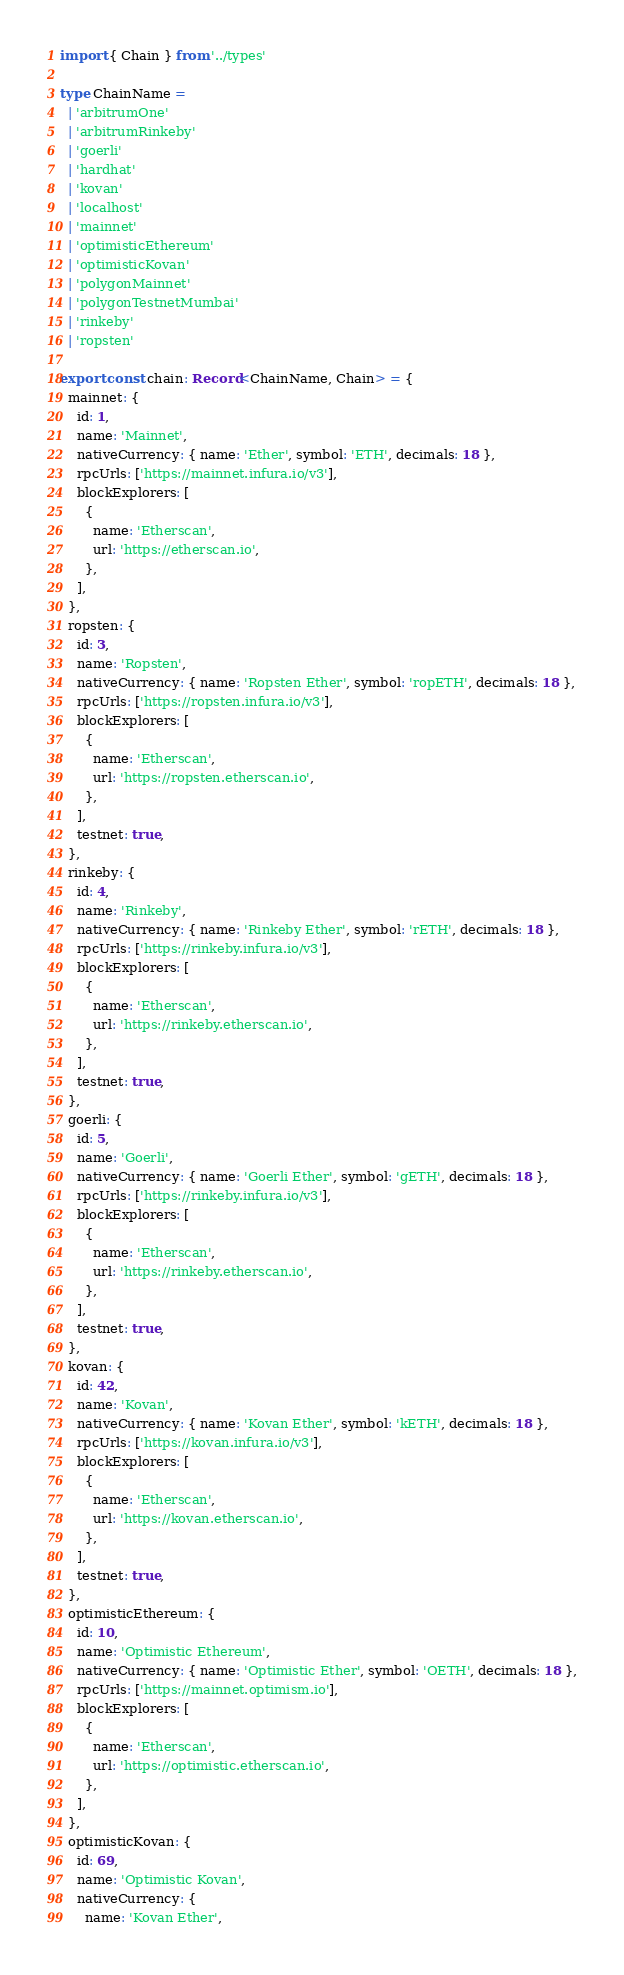Convert code to text. <code><loc_0><loc_0><loc_500><loc_500><_TypeScript_>import { Chain } from '../types'

type ChainName =
  | 'arbitrumOne'
  | 'arbitrumRinkeby'
  | 'goerli'
  | 'hardhat'
  | 'kovan'
  | 'localhost'
  | 'mainnet'
  | 'optimisticEthereum'
  | 'optimisticKovan'
  | 'polygonMainnet'
  | 'polygonTestnetMumbai'
  | 'rinkeby'
  | 'ropsten'

export const chain: Record<ChainName, Chain> = {
  mainnet: {
    id: 1,
    name: 'Mainnet',
    nativeCurrency: { name: 'Ether', symbol: 'ETH', decimals: 18 },
    rpcUrls: ['https://mainnet.infura.io/v3'],
    blockExplorers: [
      {
        name: 'Etherscan',
        url: 'https://etherscan.io',
      },
    ],
  },
  ropsten: {
    id: 3,
    name: 'Ropsten',
    nativeCurrency: { name: 'Ropsten Ether', symbol: 'ropETH', decimals: 18 },
    rpcUrls: ['https://ropsten.infura.io/v3'],
    blockExplorers: [
      {
        name: 'Etherscan',
        url: 'https://ropsten.etherscan.io',
      },
    ],
    testnet: true,
  },
  rinkeby: {
    id: 4,
    name: 'Rinkeby',
    nativeCurrency: { name: 'Rinkeby Ether', symbol: 'rETH', decimals: 18 },
    rpcUrls: ['https://rinkeby.infura.io/v3'],
    blockExplorers: [
      {
        name: 'Etherscan',
        url: 'https://rinkeby.etherscan.io',
      },
    ],
    testnet: true,
  },
  goerli: {
    id: 5,
    name: 'Goerli',
    nativeCurrency: { name: 'Goerli Ether', symbol: 'gETH', decimals: 18 },
    rpcUrls: ['https://rinkeby.infura.io/v3'],
    blockExplorers: [
      {
        name: 'Etherscan',
        url: 'https://rinkeby.etherscan.io',
      },
    ],
    testnet: true,
  },
  kovan: {
    id: 42,
    name: 'Kovan',
    nativeCurrency: { name: 'Kovan Ether', symbol: 'kETH', decimals: 18 },
    rpcUrls: ['https://kovan.infura.io/v3'],
    blockExplorers: [
      {
        name: 'Etherscan',
        url: 'https://kovan.etherscan.io',
      },
    ],
    testnet: true,
  },
  optimisticEthereum: {
    id: 10,
    name: 'Optimistic Ethereum',
    nativeCurrency: { name: 'Optimistic Ether', symbol: 'OETH', decimals: 18 },
    rpcUrls: ['https://mainnet.optimism.io'],
    blockExplorers: [
      {
        name: 'Etherscan',
        url: 'https://optimistic.etherscan.io',
      },
    ],
  },
  optimisticKovan: {
    id: 69,
    name: 'Optimistic Kovan',
    nativeCurrency: {
      name: 'Kovan Ether',</code> 